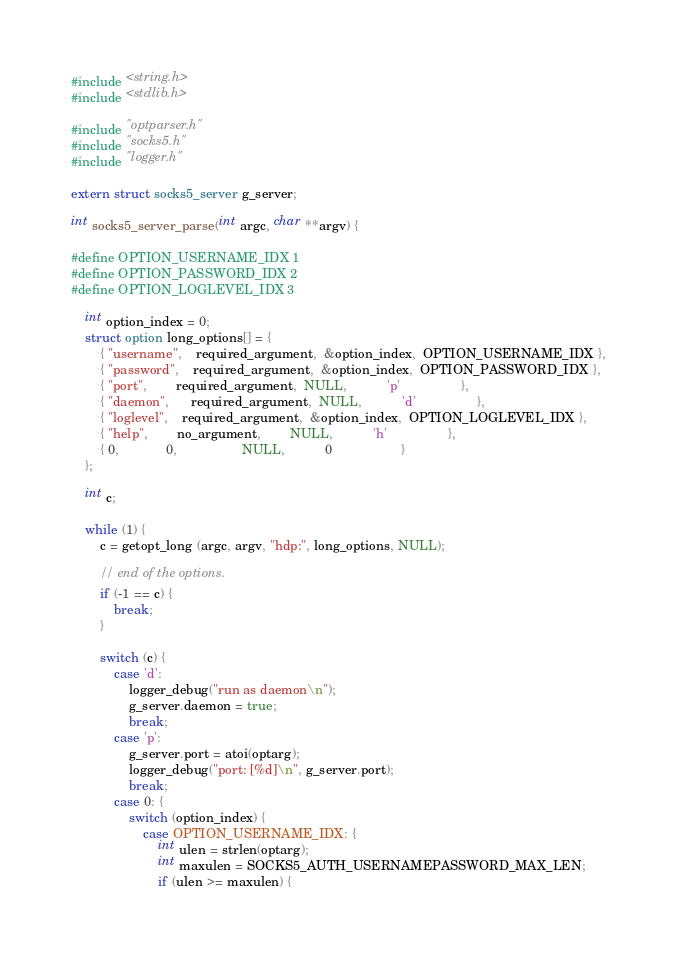Convert code to text. <code><loc_0><loc_0><loc_500><loc_500><_C_>#include <string.h>
#include <stdlib.h>

#include "optparser.h"
#include "socks5.h"
#include "logger.h"

extern struct socks5_server g_server;

int socks5_server_parse(int argc, char **argv) {

#define OPTION_USERNAME_IDX 1
#define OPTION_PASSWORD_IDX 2
#define OPTION_LOGLEVEL_IDX 3

    int option_index = 0;
    struct option long_options[] = {
        { "username",    required_argument,  &option_index,  OPTION_USERNAME_IDX },
        { "password",    required_argument,  &option_index,  OPTION_PASSWORD_IDX },
        { "port",        required_argument,  NULL,           'p'                 },
        { "daemon",      required_argument,  NULL,           'd'                 },
        { "loglevel",    required_argument,  &option_index,  OPTION_LOGLEVEL_IDX },
        { "help",        no_argument,        NULL,           'h'                 },
        { 0,             0,                  NULL,           0                   }
    };

    int c;

    while (1) {
        c = getopt_long (argc, argv, "hdp:", long_options, NULL);

        // end of the options.
        if (-1 == c) {
            break;
        }

        switch (c) {
            case 'd':
                logger_debug("run as daemon\n");
                g_server.daemon = true;
                break;
            case 'p':
                g_server.port = atoi(optarg);
                logger_debug("port: [%d]\n", g_server.port);
                break;
            case 0: {
                switch (option_index) {
                    case OPTION_USERNAME_IDX: {
                        int ulen = strlen(optarg);
                        int maxulen = SOCKS5_AUTH_USERNAMEPASSWORD_MAX_LEN;
                        if (ulen >= maxulen) {</code> 